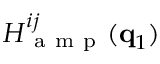<formula> <loc_0><loc_0><loc_500><loc_500>H _ { a m p } ^ { i j } ( q _ { 1 } )</formula> 